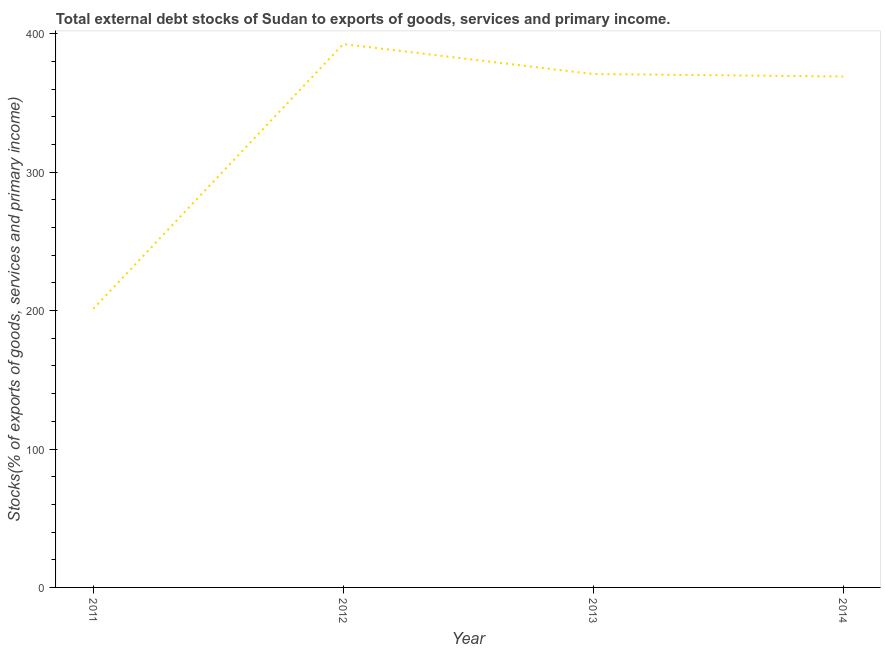What is the external debt stocks in 2012?
Provide a succinct answer. 392.61. Across all years, what is the maximum external debt stocks?
Make the answer very short. 392.61. Across all years, what is the minimum external debt stocks?
Provide a succinct answer. 201.36. In which year was the external debt stocks maximum?
Keep it short and to the point. 2012. In which year was the external debt stocks minimum?
Your response must be concise. 2011. What is the sum of the external debt stocks?
Make the answer very short. 1334.12. What is the difference between the external debt stocks in 2013 and 2014?
Offer a terse response. 1.79. What is the average external debt stocks per year?
Give a very brief answer. 333.53. What is the median external debt stocks?
Your answer should be very brief. 370.07. Do a majority of the years between 2011 and 2012 (inclusive) have external debt stocks greater than 160 %?
Ensure brevity in your answer.  Yes. What is the ratio of the external debt stocks in 2011 to that in 2013?
Your answer should be compact. 0.54. What is the difference between the highest and the second highest external debt stocks?
Your response must be concise. 21.64. Is the sum of the external debt stocks in 2012 and 2014 greater than the maximum external debt stocks across all years?
Offer a very short reply. Yes. What is the difference between the highest and the lowest external debt stocks?
Offer a terse response. 191.26. How many lines are there?
Make the answer very short. 1. What is the difference between two consecutive major ticks on the Y-axis?
Give a very brief answer. 100. Does the graph contain any zero values?
Provide a short and direct response. No. Does the graph contain grids?
Your response must be concise. No. What is the title of the graph?
Keep it short and to the point. Total external debt stocks of Sudan to exports of goods, services and primary income. What is the label or title of the Y-axis?
Your answer should be compact. Stocks(% of exports of goods, services and primary income). What is the Stocks(% of exports of goods, services and primary income) in 2011?
Provide a short and direct response. 201.36. What is the Stocks(% of exports of goods, services and primary income) in 2012?
Make the answer very short. 392.61. What is the Stocks(% of exports of goods, services and primary income) in 2013?
Make the answer very short. 370.97. What is the Stocks(% of exports of goods, services and primary income) in 2014?
Ensure brevity in your answer.  369.18. What is the difference between the Stocks(% of exports of goods, services and primary income) in 2011 and 2012?
Offer a terse response. -191.26. What is the difference between the Stocks(% of exports of goods, services and primary income) in 2011 and 2013?
Your response must be concise. -169.61. What is the difference between the Stocks(% of exports of goods, services and primary income) in 2011 and 2014?
Provide a succinct answer. -167.82. What is the difference between the Stocks(% of exports of goods, services and primary income) in 2012 and 2013?
Your response must be concise. 21.64. What is the difference between the Stocks(% of exports of goods, services and primary income) in 2012 and 2014?
Your answer should be very brief. 23.43. What is the difference between the Stocks(% of exports of goods, services and primary income) in 2013 and 2014?
Your answer should be very brief. 1.79. What is the ratio of the Stocks(% of exports of goods, services and primary income) in 2011 to that in 2012?
Provide a short and direct response. 0.51. What is the ratio of the Stocks(% of exports of goods, services and primary income) in 2011 to that in 2013?
Give a very brief answer. 0.54. What is the ratio of the Stocks(% of exports of goods, services and primary income) in 2011 to that in 2014?
Give a very brief answer. 0.55. What is the ratio of the Stocks(% of exports of goods, services and primary income) in 2012 to that in 2013?
Offer a terse response. 1.06. What is the ratio of the Stocks(% of exports of goods, services and primary income) in 2012 to that in 2014?
Your answer should be very brief. 1.06. What is the ratio of the Stocks(% of exports of goods, services and primary income) in 2013 to that in 2014?
Your response must be concise. 1. 